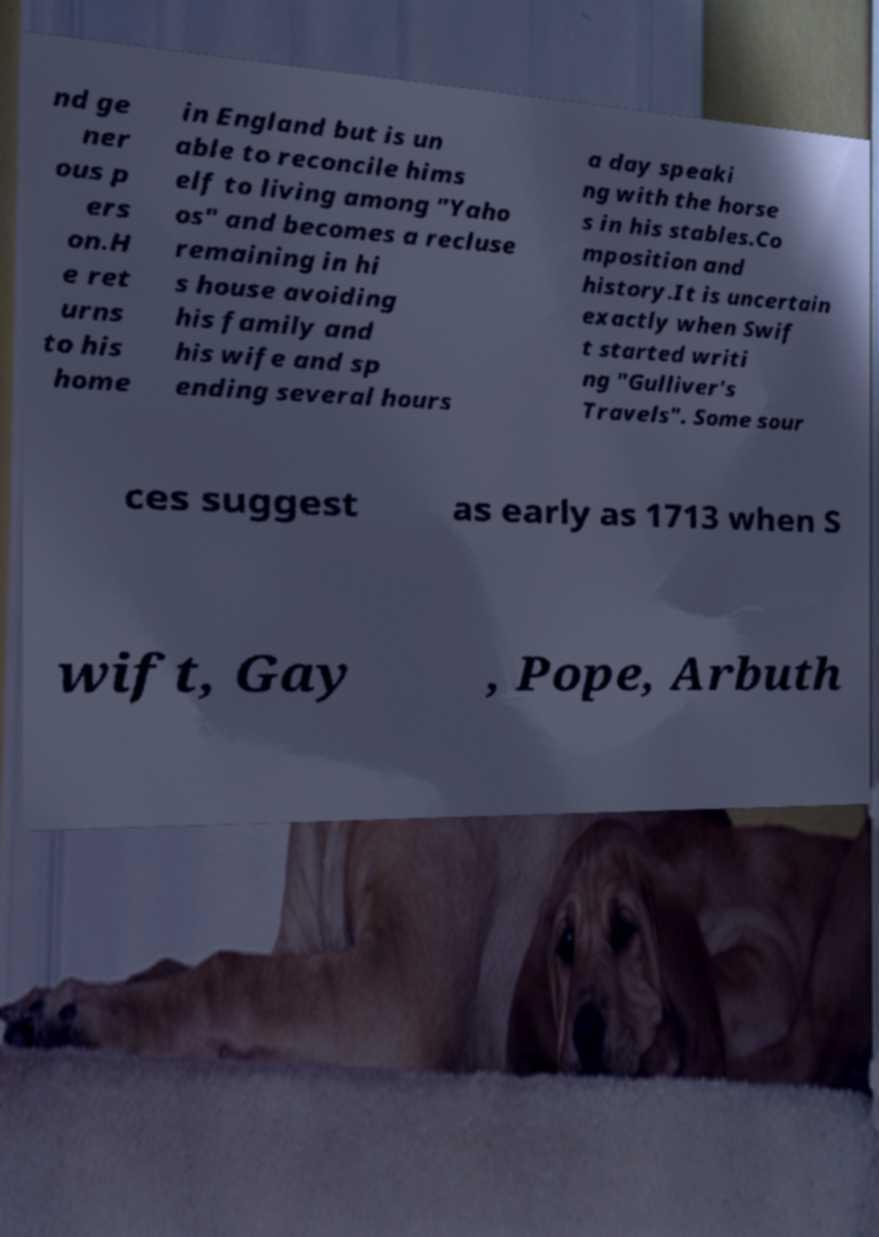What messages or text are displayed in this image? I need them in a readable, typed format. nd ge ner ous p ers on.H e ret urns to his home in England but is un able to reconcile hims elf to living among "Yaho os" and becomes a recluse remaining in hi s house avoiding his family and his wife and sp ending several hours a day speaki ng with the horse s in his stables.Co mposition and history.It is uncertain exactly when Swif t started writi ng "Gulliver's Travels". Some sour ces suggest as early as 1713 when S wift, Gay , Pope, Arbuth 